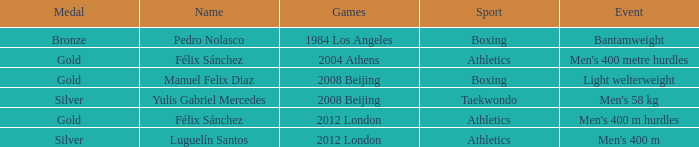What games carried the name of manuel felix diaz? 2008 Beijing. 